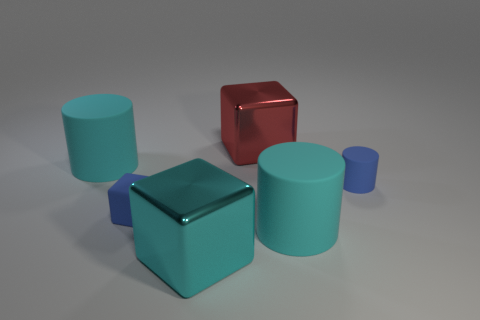There is a small matte cylinder; does it have the same color as the small object left of the large red cube?
Make the answer very short. Yes. Is there any other thing that has the same color as the tiny block?
Make the answer very short. Yes. Are there fewer big objects that are to the right of the red shiny thing than large metal things?
Your answer should be compact. Yes. Are there any tiny blue rubber blocks behind the small cylinder?
Your response must be concise. No. Are there any cyan things that have the same shape as the large red object?
Ensure brevity in your answer.  Yes. There is another metal object that is the same size as the red thing; what shape is it?
Offer a terse response. Cube. What number of things are either big metal cubes in front of the blue rubber block or small objects?
Keep it short and to the point. 3. Is the tiny matte block the same color as the tiny matte cylinder?
Your response must be concise. Yes. There is a blue matte thing that is on the left side of the red metal cube; how big is it?
Your response must be concise. Small. Is there another shiny object of the same size as the red object?
Keep it short and to the point. Yes. 